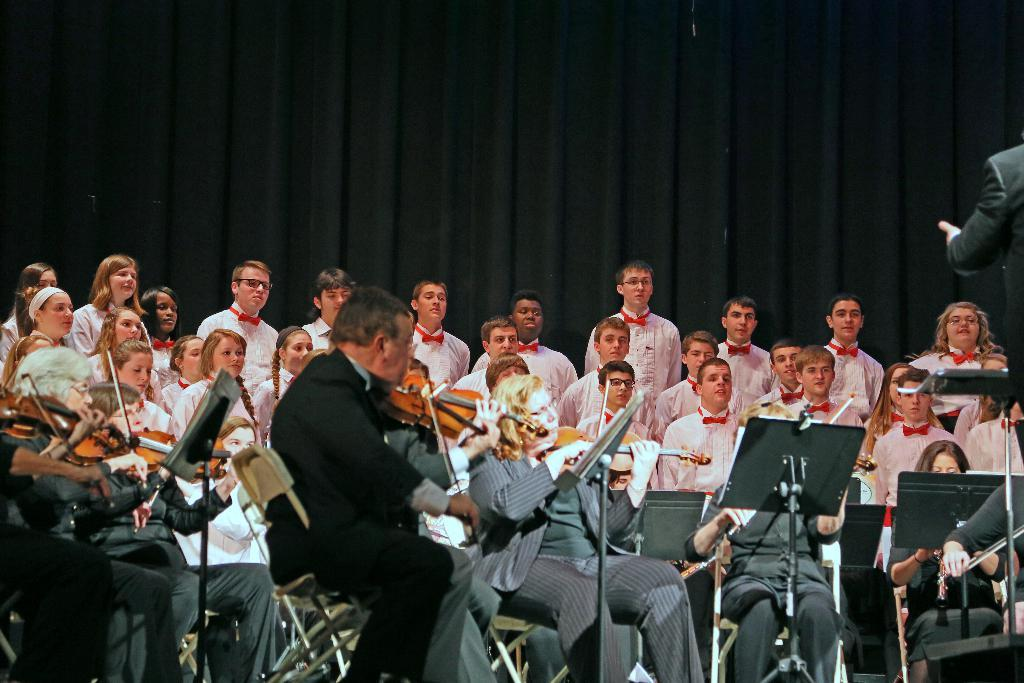What are the persons in the image doing? The persons in the image are playing musical instruments. Can you describe the people in the background of the image? There are people in the background of the image, but their specific actions or characteristics are not mentioned in the provided facts. What type of polish is being applied to the instruments in the image? There is no mention of polish or any maintenance activity being performed on the instruments in the image. 